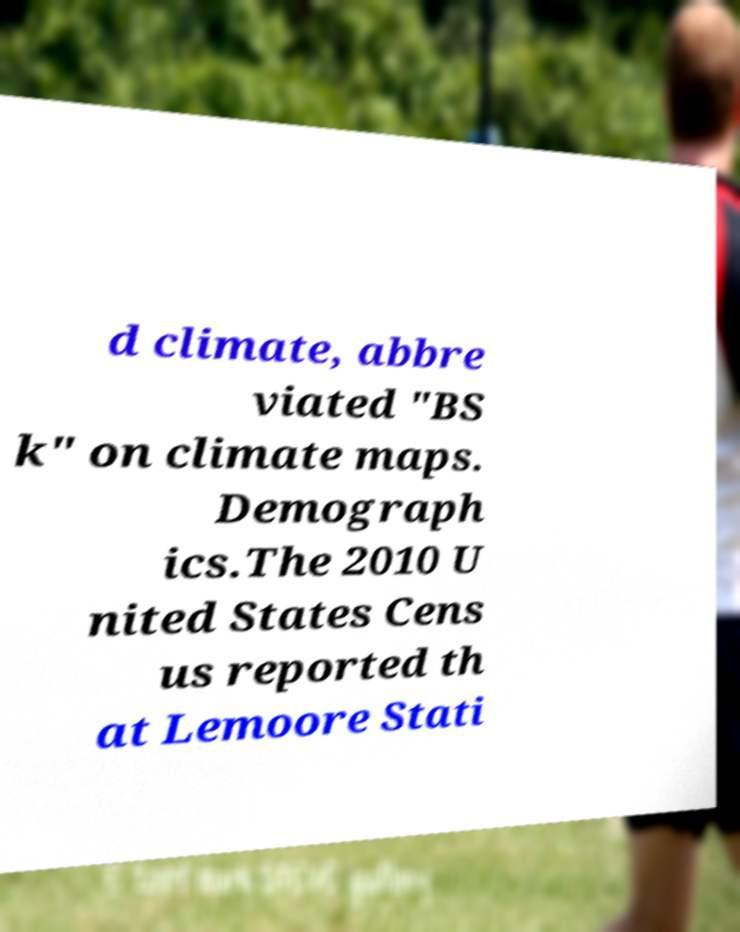I need the written content from this picture converted into text. Can you do that? d climate, abbre viated "BS k" on climate maps. Demograph ics.The 2010 U nited States Cens us reported th at Lemoore Stati 